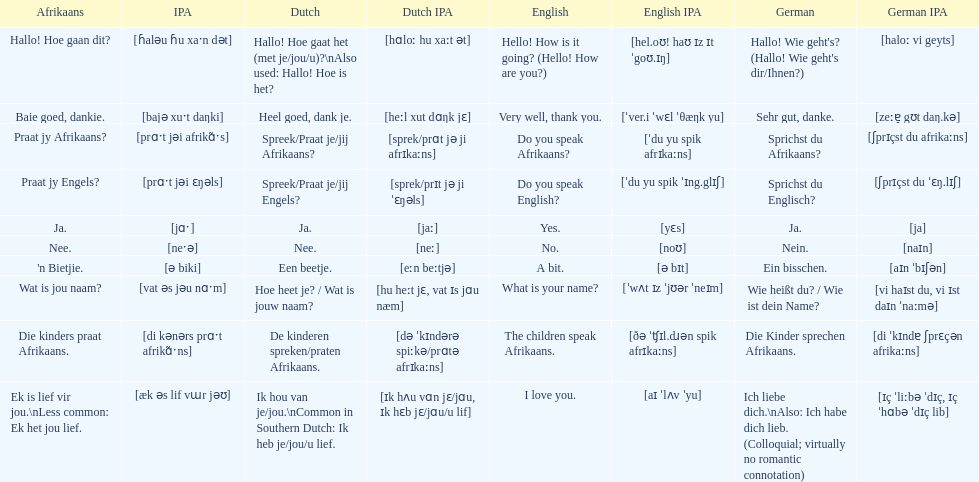Translate the following into german: die kinders praat afrikaans. Die Kinder sprechen Afrikaans. 